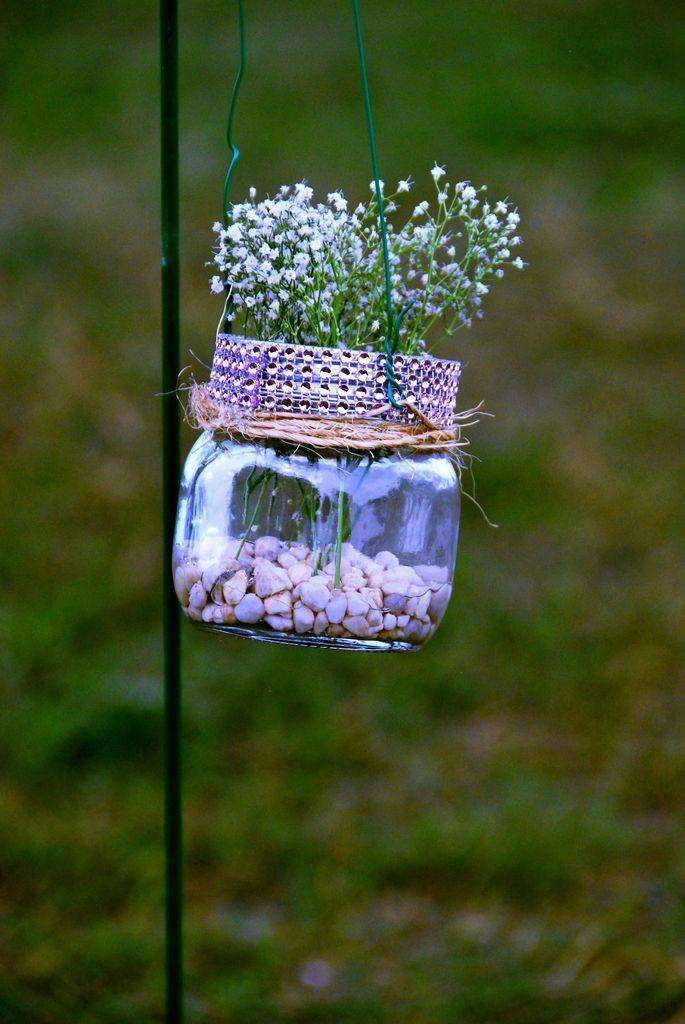What object is present in the image that contains items? There is a glass jar in the image that contains items. What can be found inside the glass jar? There are stones and tiny flowers in the glass jar. What can be inferred about the background of the image? The background of the image appears to be greenish. Can you hear a whistle in the image? There is no whistle present in the image, as it is a still image and cannot produce sound. 